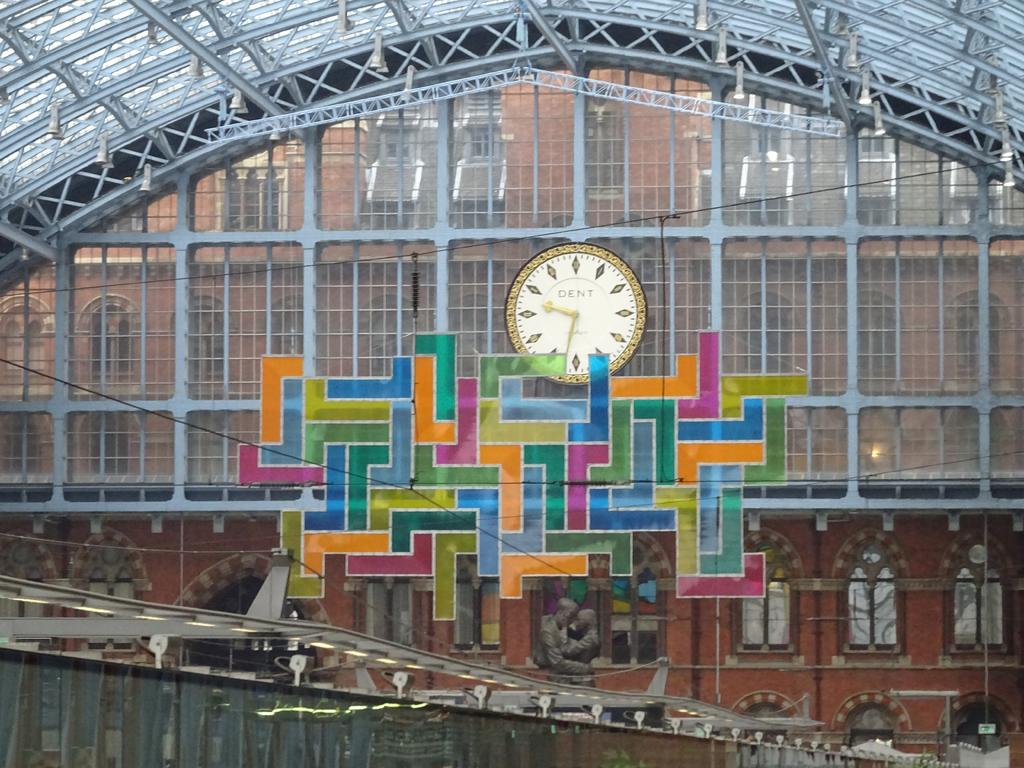What type of structure is visible in the image? There is a building in the image. What features can be observed on the building? The building has windows and a roof. What time-telling device is present in the image? There is a clock in the image. What additional structures can be seen in the image? There is a bridge, a shed, and a wall visible in the image. What objects are present near the building? There are rods, poles, and sign boards in the image. Are there any statues in the image? Yes, there is a statue in the image. Can you tell me where the river flows in the image? There is no river present in the image. What type of church can be seen in the background of the image? There is no church visible in the image. 